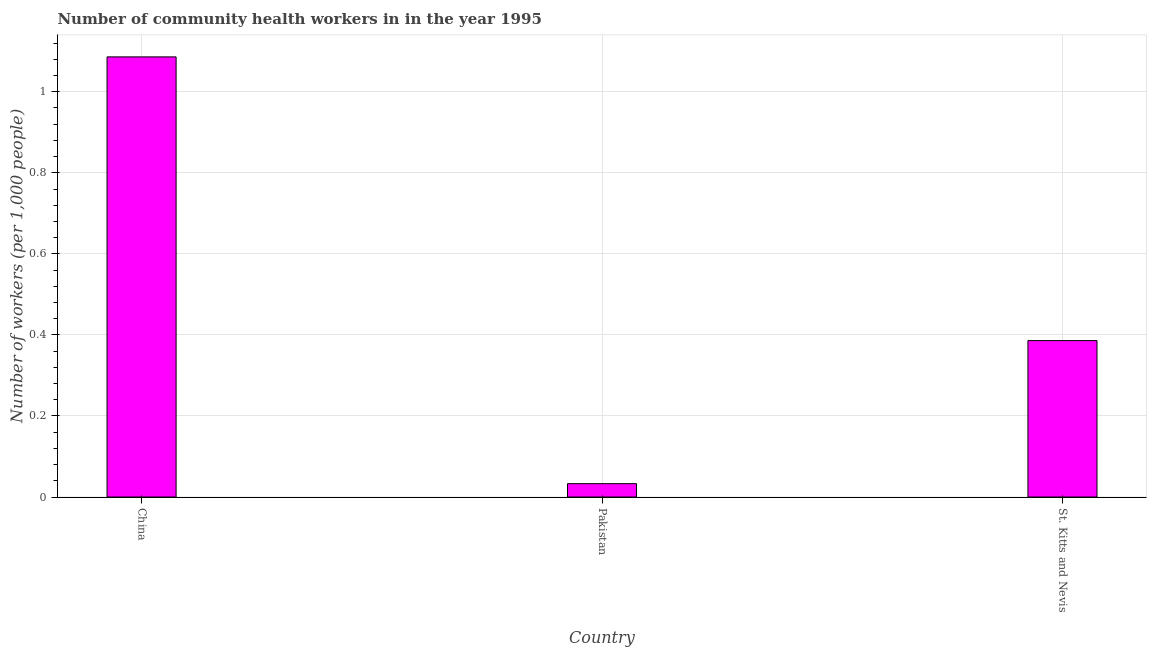What is the title of the graph?
Offer a terse response. Number of community health workers in in the year 1995. What is the label or title of the Y-axis?
Your answer should be very brief. Number of workers (per 1,0 people). What is the number of community health workers in St. Kitts and Nevis?
Make the answer very short. 0.39. Across all countries, what is the maximum number of community health workers?
Ensure brevity in your answer.  1.09. Across all countries, what is the minimum number of community health workers?
Give a very brief answer. 0.03. What is the sum of the number of community health workers?
Make the answer very short. 1.5. What is the average number of community health workers per country?
Provide a succinct answer. 0.5. What is the median number of community health workers?
Provide a succinct answer. 0.39. In how many countries, is the number of community health workers greater than 0.8 ?
Your answer should be compact. 1. What is the ratio of the number of community health workers in Pakistan to that in St. Kitts and Nevis?
Offer a terse response. 0.09. What is the difference between the highest and the lowest number of community health workers?
Your answer should be very brief. 1.05. How many bars are there?
Keep it short and to the point. 3. Are all the bars in the graph horizontal?
Your answer should be compact. No. What is the difference between two consecutive major ticks on the Y-axis?
Your answer should be compact. 0.2. What is the Number of workers (per 1,000 people) in China?
Provide a short and direct response. 1.09. What is the Number of workers (per 1,000 people) in Pakistan?
Offer a very short reply. 0.03. What is the Number of workers (per 1,000 people) in St. Kitts and Nevis?
Offer a terse response. 0.39. What is the difference between the Number of workers (per 1,000 people) in China and Pakistan?
Your response must be concise. 1.05. What is the difference between the Number of workers (per 1,000 people) in Pakistan and St. Kitts and Nevis?
Your answer should be very brief. -0.35. What is the ratio of the Number of workers (per 1,000 people) in China to that in Pakistan?
Ensure brevity in your answer.  32.91. What is the ratio of the Number of workers (per 1,000 people) in China to that in St. Kitts and Nevis?
Your answer should be very brief. 2.81. What is the ratio of the Number of workers (per 1,000 people) in Pakistan to that in St. Kitts and Nevis?
Provide a succinct answer. 0.09. 